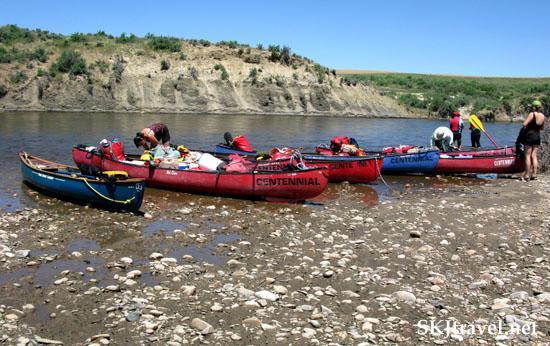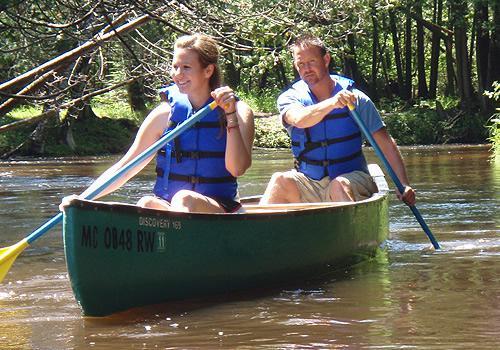The first image is the image on the left, the second image is the image on the right. For the images displayed, is the sentence "there are exactly two people in the image on the right" factually correct? Answer yes or no. Yes. The first image is the image on the left, the second image is the image on the right. Given the left and right images, does the statement "There's at least one yellow paddle shown." hold true? Answer yes or no. Yes. 